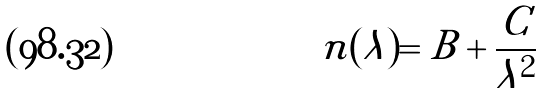Convert formula to latex. <formula><loc_0><loc_0><loc_500><loc_500>n ( \lambda ) = B + \frac { C } { \lambda ^ { 2 } }</formula> 